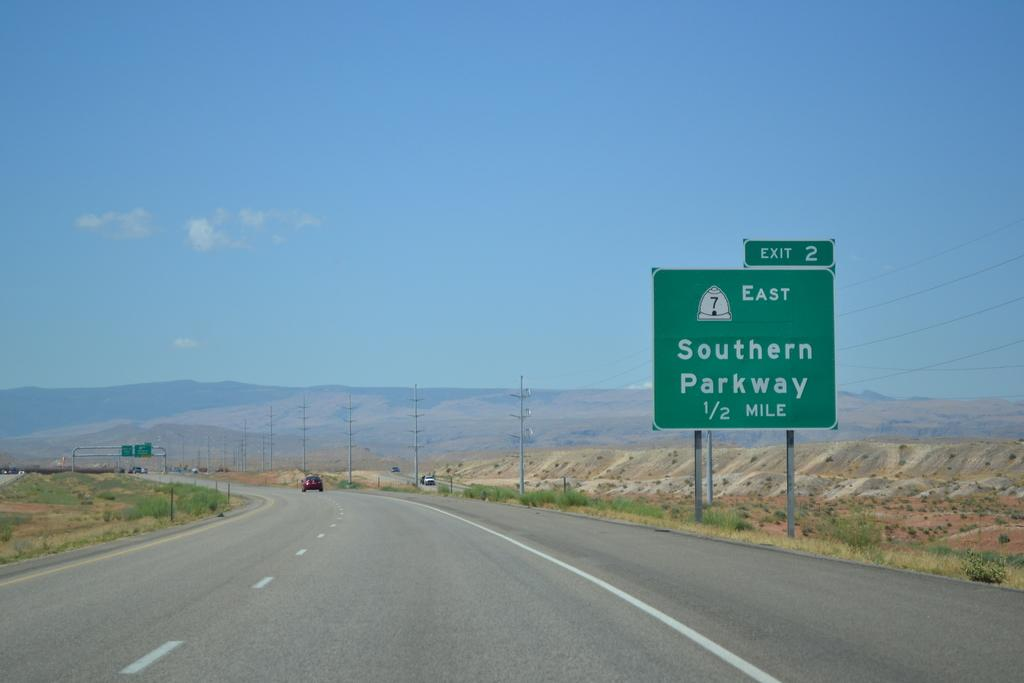<image>
Share a concise interpretation of the image provided. The sign on the highway is for Exit 2 for the Southern Parkway. 